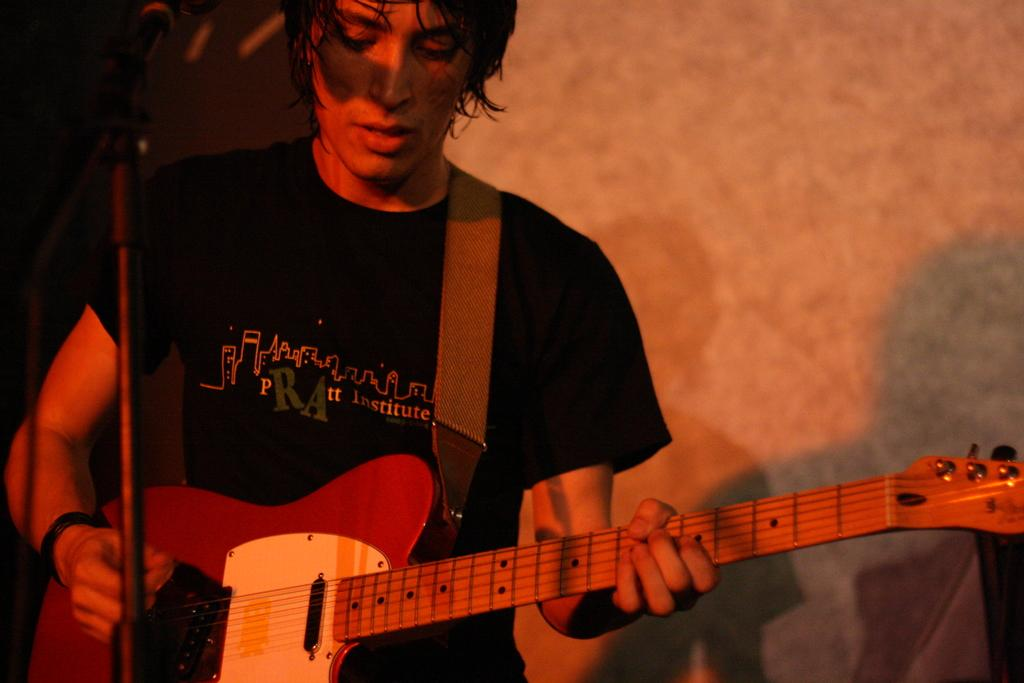What is the man in the image doing? The man is singing and playing a guitar. What is the man wearing in the image? The man is wearing a black t-shirt. What object is the man standing in front of? The man is standing in front of a microphone. What type of hammer is the man using to play the guitar in the image? There is no hammer present in the image; the man is playing the guitar with his hands. Is the man wearing a mask in the image? No, the man is not wearing a mask in the image; he is only wearing a black t-shirt. 